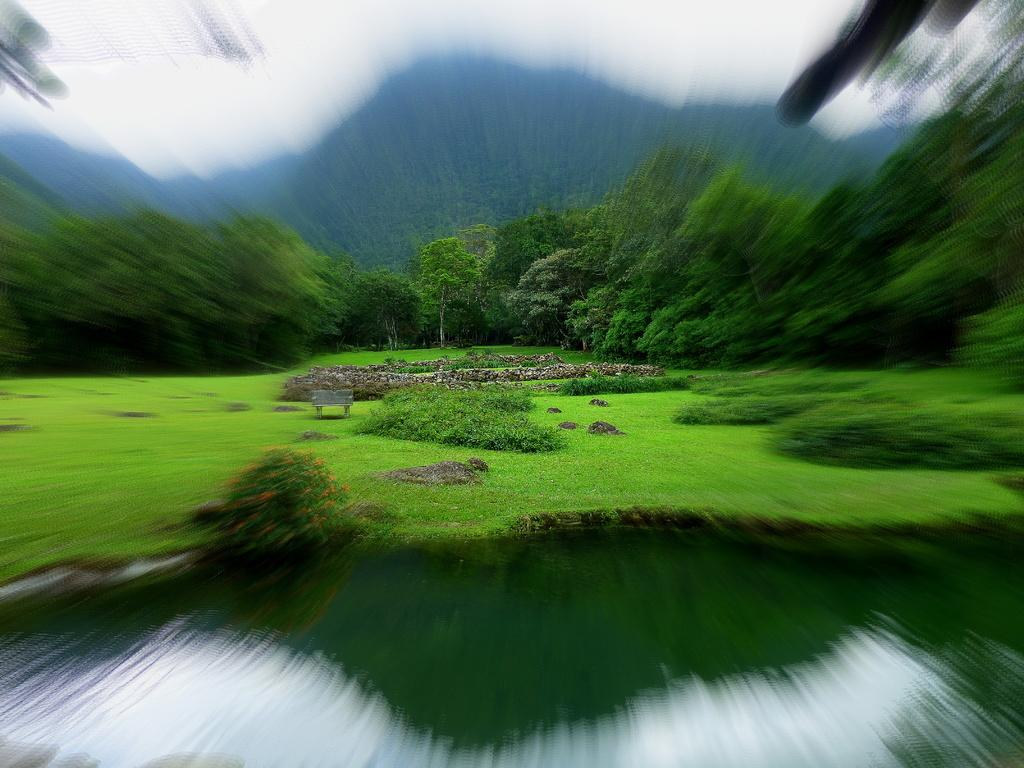What type of vegetation can be seen in the image? There are plants, grass, and trees visible in the image. What natural feature is present in the image? There is water visible in the image. What is the texture of the object in the image? There is a stone in the image, which has a rough texture. What geographical feature can be seen in the distance? There are mountains in the image. What part of the natural environment is visible in the image? The sky is visible in the image. What type of vegetable is being used as a shirt in the image? There is no vegetable being used as a shirt in the image. What team is playing in the image? There is no team or sporting event depicted in the image. 